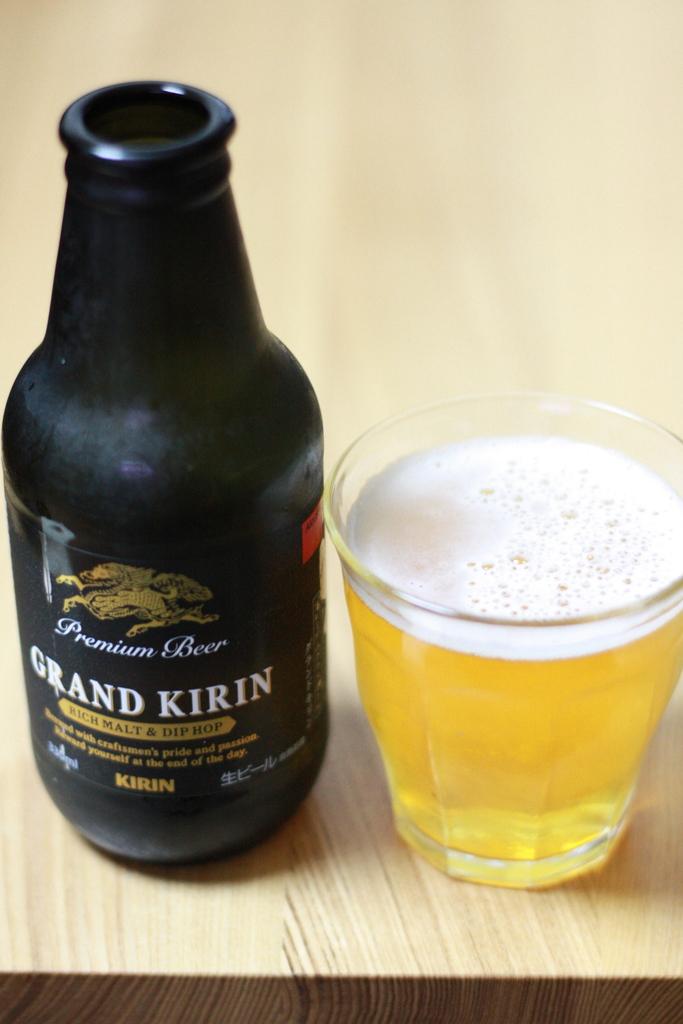What is the name of the beer in the bottle?
Offer a very short reply. Grand kirin. What is the first word on the bottle?
Offer a very short reply. Grand. 